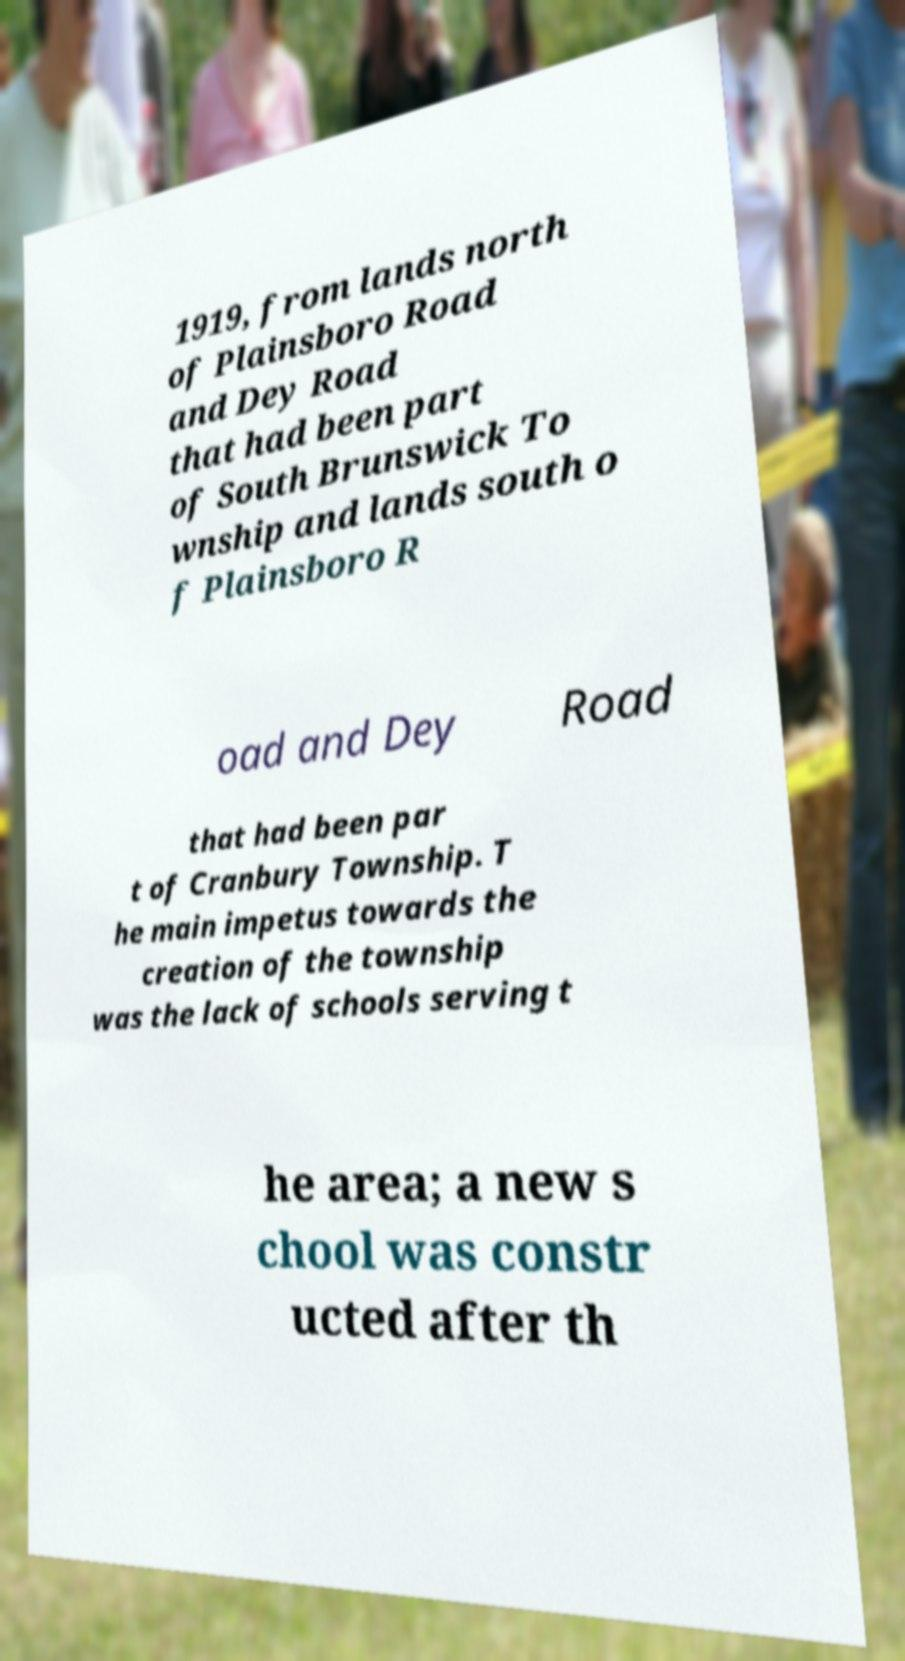Could you extract and type out the text from this image? 1919, from lands north of Plainsboro Road and Dey Road that had been part of South Brunswick To wnship and lands south o f Plainsboro R oad and Dey Road that had been par t of Cranbury Township. T he main impetus towards the creation of the township was the lack of schools serving t he area; a new s chool was constr ucted after th 